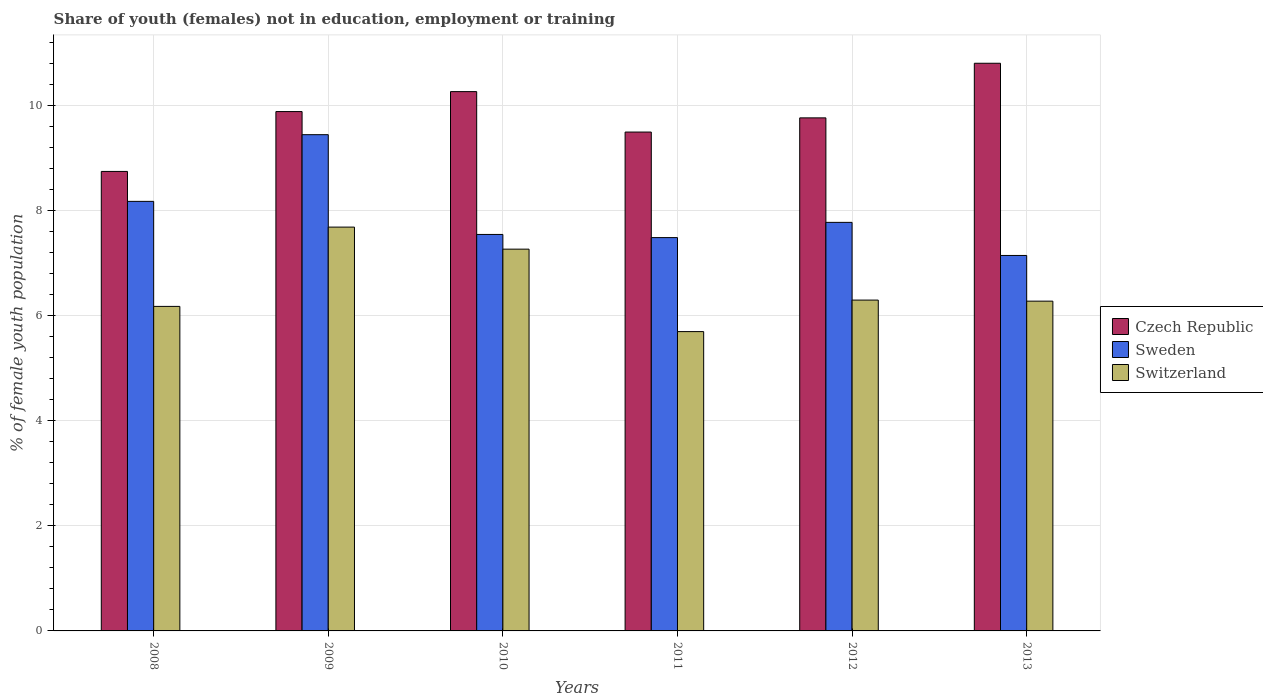Are the number of bars on each tick of the X-axis equal?
Offer a terse response. Yes. What is the label of the 5th group of bars from the left?
Ensure brevity in your answer.  2012. What is the percentage of unemployed female population in in Sweden in 2010?
Your response must be concise. 7.55. Across all years, what is the maximum percentage of unemployed female population in in Czech Republic?
Offer a terse response. 10.81. Across all years, what is the minimum percentage of unemployed female population in in Sweden?
Offer a very short reply. 7.15. What is the total percentage of unemployed female population in in Sweden in the graph?
Give a very brief answer. 47.6. What is the difference between the percentage of unemployed female population in in Switzerland in 2011 and that in 2012?
Your answer should be very brief. -0.6. What is the difference between the percentage of unemployed female population in in Switzerland in 2011 and the percentage of unemployed female population in in Czech Republic in 2012?
Provide a succinct answer. -4.07. What is the average percentage of unemployed female population in in Czech Republic per year?
Your answer should be very brief. 9.83. In the year 2012, what is the difference between the percentage of unemployed female population in in Czech Republic and percentage of unemployed female population in in Sweden?
Your answer should be compact. 1.99. What is the ratio of the percentage of unemployed female population in in Switzerland in 2010 to that in 2013?
Offer a terse response. 1.16. Is the percentage of unemployed female population in in Sweden in 2008 less than that in 2010?
Ensure brevity in your answer.  No. What is the difference between the highest and the second highest percentage of unemployed female population in in Czech Republic?
Provide a succinct answer. 0.54. What is the difference between the highest and the lowest percentage of unemployed female population in in Czech Republic?
Keep it short and to the point. 2.06. In how many years, is the percentage of unemployed female population in in Sweden greater than the average percentage of unemployed female population in in Sweden taken over all years?
Your response must be concise. 2. Is the sum of the percentage of unemployed female population in in Switzerland in 2008 and 2010 greater than the maximum percentage of unemployed female population in in Sweden across all years?
Offer a terse response. Yes. What does the 2nd bar from the left in 2009 represents?
Offer a terse response. Sweden. What does the 3rd bar from the right in 2012 represents?
Your answer should be compact. Czech Republic. Is it the case that in every year, the sum of the percentage of unemployed female population in in Switzerland and percentage of unemployed female population in in Czech Republic is greater than the percentage of unemployed female population in in Sweden?
Your answer should be very brief. Yes. How many bars are there?
Provide a succinct answer. 18. What is the difference between two consecutive major ticks on the Y-axis?
Ensure brevity in your answer.  2. Are the values on the major ticks of Y-axis written in scientific E-notation?
Keep it short and to the point. No. How many legend labels are there?
Your answer should be very brief. 3. How are the legend labels stacked?
Provide a succinct answer. Vertical. What is the title of the graph?
Your answer should be very brief. Share of youth (females) not in education, employment or training. Does "Aruba" appear as one of the legend labels in the graph?
Your answer should be very brief. No. What is the label or title of the Y-axis?
Ensure brevity in your answer.  % of female youth population. What is the % of female youth population of Czech Republic in 2008?
Provide a succinct answer. 8.75. What is the % of female youth population of Sweden in 2008?
Offer a very short reply. 8.18. What is the % of female youth population in Switzerland in 2008?
Keep it short and to the point. 6.18. What is the % of female youth population of Czech Republic in 2009?
Keep it short and to the point. 9.89. What is the % of female youth population of Sweden in 2009?
Give a very brief answer. 9.45. What is the % of female youth population in Switzerland in 2009?
Offer a terse response. 7.69. What is the % of female youth population of Czech Republic in 2010?
Your answer should be compact. 10.27. What is the % of female youth population in Sweden in 2010?
Provide a succinct answer. 7.55. What is the % of female youth population in Switzerland in 2010?
Make the answer very short. 7.27. What is the % of female youth population in Czech Republic in 2011?
Your answer should be very brief. 9.5. What is the % of female youth population in Sweden in 2011?
Offer a very short reply. 7.49. What is the % of female youth population in Switzerland in 2011?
Keep it short and to the point. 5.7. What is the % of female youth population in Czech Republic in 2012?
Your response must be concise. 9.77. What is the % of female youth population of Sweden in 2012?
Give a very brief answer. 7.78. What is the % of female youth population in Switzerland in 2012?
Offer a terse response. 6.3. What is the % of female youth population in Czech Republic in 2013?
Provide a short and direct response. 10.81. What is the % of female youth population of Sweden in 2013?
Provide a short and direct response. 7.15. What is the % of female youth population of Switzerland in 2013?
Your response must be concise. 6.28. Across all years, what is the maximum % of female youth population in Czech Republic?
Provide a succinct answer. 10.81. Across all years, what is the maximum % of female youth population in Sweden?
Your answer should be compact. 9.45. Across all years, what is the maximum % of female youth population in Switzerland?
Keep it short and to the point. 7.69. Across all years, what is the minimum % of female youth population in Czech Republic?
Provide a succinct answer. 8.75. Across all years, what is the minimum % of female youth population in Sweden?
Your response must be concise. 7.15. Across all years, what is the minimum % of female youth population in Switzerland?
Your answer should be compact. 5.7. What is the total % of female youth population in Czech Republic in the graph?
Offer a very short reply. 58.99. What is the total % of female youth population of Sweden in the graph?
Your answer should be compact. 47.6. What is the total % of female youth population of Switzerland in the graph?
Provide a succinct answer. 39.42. What is the difference between the % of female youth population in Czech Republic in 2008 and that in 2009?
Provide a succinct answer. -1.14. What is the difference between the % of female youth population in Sweden in 2008 and that in 2009?
Provide a short and direct response. -1.27. What is the difference between the % of female youth population of Switzerland in 2008 and that in 2009?
Give a very brief answer. -1.51. What is the difference between the % of female youth population in Czech Republic in 2008 and that in 2010?
Offer a terse response. -1.52. What is the difference between the % of female youth population of Sweden in 2008 and that in 2010?
Provide a short and direct response. 0.63. What is the difference between the % of female youth population of Switzerland in 2008 and that in 2010?
Your answer should be very brief. -1.09. What is the difference between the % of female youth population in Czech Republic in 2008 and that in 2011?
Offer a very short reply. -0.75. What is the difference between the % of female youth population of Sweden in 2008 and that in 2011?
Give a very brief answer. 0.69. What is the difference between the % of female youth population in Switzerland in 2008 and that in 2011?
Make the answer very short. 0.48. What is the difference between the % of female youth population of Czech Republic in 2008 and that in 2012?
Provide a succinct answer. -1.02. What is the difference between the % of female youth population of Sweden in 2008 and that in 2012?
Provide a succinct answer. 0.4. What is the difference between the % of female youth population in Switzerland in 2008 and that in 2012?
Make the answer very short. -0.12. What is the difference between the % of female youth population in Czech Republic in 2008 and that in 2013?
Your answer should be compact. -2.06. What is the difference between the % of female youth population in Sweden in 2008 and that in 2013?
Give a very brief answer. 1.03. What is the difference between the % of female youth population in Switzerland in 2008 and that in 2013?
Provide a short and direct response. -0.1. What is the difference between the % of female youth population of Czech Republic in 2009 and that in 2010?
Offer a very short reply. -0.38. What is the difference between the % of female youth population of Switzerland in 2009 and that in 2010?
Provide a succinct answer. 0.42. What is the difference between the % of female youth population in Czech Republic in 2009 and that in 2011?
Provide a short and direct response. 0.39. What is the difference between the % of female youth population of Sweden in 2009 and that in 2011?
Make the answer very short. 1.96. What is the difference between the % of female youth population of Switzerland in 2009 and that in 2011?
Provide a short and direct response. 1.99. What is the difference between the % of female youth population of Czech Republic in 2009 and that in 2012?
Give a very brief answer. 0.12. What is the difference between the % of female youth population of Sweden in 2009 and that in 2012?
Give a very brief answer. 1.67. What is the difference between the % of female youth population of Switzerland in 2009 and that in 2012?
Your answer should be very brief. 1.39. What is the difference between the % of female youth population in Czech Republic in 2009 and that in 2013?
Your response must be concise. -0.92. What is the difference between the % of female youth population in Sweden in 2009 and that in 2013?
Your answer should be compact. 2.3. What is the difference between the % of female youth population in Switzerland in 2009 and that in 2013?
Offer a terse response. 1.41. What is the difference between the % of female youth population of Czech Republic in 2010 and that in 2011?
Provide a succinct answer. 0.77. What is the difference between the % of female youth population of Sweden in 2010 and that in 2011?
Keep it short and to the point. 0.06. What is the difference between the % of female youth population of Switzerland in 2010 and that in 2011?
Ensure brevity in your answer.  1.57. What is the difference between the % of female youth population in Czech Republic in 2010 and that in 2012?
Keep it short and to the point. 0.5. What is the difference between the % of female youth population of Sweden in 2010 and that in 2012?
Offer a terse response. -0.23. What is the difference between the % of female youth population of Czech Republic in 2010 and that in 2013?
Keep it short and to the point. -0.54. What is the difference between the % of female youth population of Czech Republic in 2011 and that in 2012?
Ensure brevity in your answer.  -0.27. What is the difference between the % of female youth population in Sweden in 2011 and that in 2012?
Provide a succinct answer. -0.29. What is the difference between the % of female youth population of Czech Republic in 2011 and that in 2013?
Offer a terse response. -1.31. What is the difference between the % of female youth population of Sweden in 2011 and that in 2013?
Provide a short and direct response. 0.34. What is the difference between the % of female youth population in Switzerland in 2011 and that in 2013?
Offer a very short reply. -0.58. What is the difference between the % of female youth population of Czech Republic in 2012 and that in 2013?
Give a very brief answer. -1.04. What is the difference between the % of female youth population of Sweden in 2012 and that in 2013?
Your response must be concise. 0.63. What is the difference between the % of female youth population of Switzerland in 2012 and that in 2013?
Make the answer very short. 0.02. What is the difference between the % of female youth population in Czech Republic in 2008 and the % of female youth population in Switzerland in 2009?
Your response must be concise. 1.06. What is the difference between the % of female youth population of Sweden in 2008 and the % of female youth population of Switzerland in 2009?
Your answer should be very brief. 0.49. What is the difference between the % of female youth population in Czech Republic in 2008 and the % of female youth population in Sweden in 2010?
Your response must be concise. 1.2. What is the difference between the % of female youth population in Czech Republic in 2008 and the % of female youth population in Switzerland in 2010?
Make the answer very short. 1.48. What is the difference between the % of female youth population of Sweden in 2008 and the % of female youth population of Switzerland in 2010?
Your answer should be very brief. 0.91. What is the difference between the % of female youth population in Czech Republic in 2008 and the % of female youth population in Sweden in 2011?
Make the answer very short. 1.26. What is the difference between the % of female youth population in Czech Republic in 2008 and the % of female youth population in Switzerland in 2011?
Keep it short and to the point. 3.05. What is the difference between the % of female youth population of Sweden in 2008 and the % of female youth population of Switzerland in 2011?
Your answer should be compact. 2.48. What is the difference between the % of female youth population of Czech Republic in 2008 and the % of female youth population of Sweden in 2012?
Ensure brevity in your answer.  0.97. What is the difference between the % of female youth population of Czech Republic in 2008 and the % of female youth population of Switzerland in 2012?
Give a very brief answer. 2.45. What is the difference between the % of female youth population in Sweden in 2008 and the % of female youth population in Switzerland in 2012?
Your response must be concise. 1.88. What is the difference between the % of female youth population in Czech Republic in 2008 and the % of female youth population in Switzerland in 2013?
Your answer should be compact. 2.47. What is the difference between the % of female youth population of Sweden in 2008 and the % of female youth population of Switzerland in 2013?
Provide a short and direct response. 1.9. What is the difference between the % of female youth population of Czech Republic in 2009 and the % of female youth population of Sweden in 2010?
Ensure brevity in your answer.  2.34. What is the difference between the % of female youth population of Czech Republic in 2009 and the % of female youth population of Switzerland in 2010?
Make the answer very short. 2.62. What is the difference between the % of female youth population in Sweden in 2009 and the % of female youth population in Switzerland in 2010?
Provide a succinct answer. 2.18. What is the difference between the % of female youth population of Czech Republic in 2009 and the % of female youth population of Switzerland in 2011?
Your answer should be very brief. 4.19. What is the difference between the % of female youth population of Sweden in 2009 and the % of female youth population of Switzerland in 2011?
Your answer should be compact. 3.75. What is the difference between the % of female youth population in Czech Republic in 2009 and the % of female youth population in Sweden in 2012?
Keep it short and to the point. 2.11. What is the difference between the % of female youth population of Czech Republic in 2009 and the % of female youth population of Switzerland in 2012?
Offer a terse response. 3.59. What is the difference between the % of female youth population in Sweden in 2009 and the % of female youth population in Switzerland in 2012?
Provide a short and direct response. 3.15. What is the difference between the % of female youth population in Czech Republic in 2009 and the % of female youth population in Sweden in 2013?
Your answer should be very brief. 2.74. What is the difference between the % of female youth population in Czech Republic in 2009 and the % of female youth population in Switzerland in 2013?
Ensure brevity in your answer.  3.61. What is the difference between the % of female youth population in Sweden in 2009 and the % of female youth population in Switzerland in 2013?
Your response must be concise. 3.17. What is the difference between the % of female youth population in Czech Republic in 2010 and the % of female youth population in Sweden in 2011?
Your answer should be very brief. 2.78. What is the difference between the % of female youth population in Czech Republic in 2010 and the % of female youth population in Switzerland in 2011?
Keep it short and to the point. 4.57. What is the difference between the % of female youth population in Sweden in 2010 and the % of female youth population in Switzerland in 2011?
Provide a short and direct response. 1.85. What is the difference between the % of female youth population of Czech Republic in 2010 and the % of female youth population of Sweden in 2012?
Offer a very short reply. 2.49. What is the difference between the % of female youth population of Czech Republic in 2010 and the % of female youth population of Switzerland in 2012?
Your answer should be compact. 3.97. What is the difference between the % of female youth population in Sweden in 2010 and the % of female youth population in Switzerland in 2012?
Make the answer very short. 1.25. What is the difference between the % of female youth population of Czech Republic in 2010 and the % of female youth population of Sweden in 2013?
Provide a short and direct response. 3.12. What is the difference between the % of female youth population of Czech Republic in 2010 and the % of female youth population of Switzerland in 2013?
Provide a short and direct response. 3.99. What is the difference between the % of female youth population of Sweden in 2010 and the % of female youth population of Switzerland in 2013?
Keep it short and to the point. 1.27. What is the difference between the % of female youth population of Czech Republic in 2011 and the % of female youth population of Sweden in 2012?
Your answer should be compact. 1.72. What is the difference between the % of female youth population of Czech Republic in 2011 and the % of female youth population of Switzerland in 2012?
Provide a succinct answer. 3.2. What is the difference between the % of female youth population in Sweden in 2011 and the % of female youth population in Switzerland in 2012?
Make the answer very short. 1.19. What is the difference between the % of female youth population in Czech Republic in 2011 and the % of female youth population in Sweden in 2013?
Give a very brief answer. 2.35. What is the difference between the % of female youth population of Czech Republic in 2011 and the % of female youth population of Switzerland in 2013?
Give a very brief answer. 3.22. What is the difference between the % of female youth population of Sweden in 2011 and the % of female youth population of Switzerland in 2013?
Provide a short and direct response. 1.21. What is the difference between the % of female youth population in Czech Republic in 2012 and the % of female youth population in Sweden in 2013?
Make the answer very short. 2.62. What is the difference between the % of female youth population in Czech Republic in 2012 and the % of female youth population in Switzerland in 2013?
Offer a terse response. 3.49. What is the average % of female youth population in Czech Republic per year?
Make the answer very short. 9.83. What is the average % of female youth population in Sweden per year?
Provide a succinct answer. 7.93. What is the average % of female youth population of Switzerland per year?
Offer a terse response. 6.57. In the year 2008, what is the difference between the % of female youth population in Czech Republic and % of female youth population in Sweden?
Your response must be concise. 0.57. In the year 2008, what is the difference between the % of female youth population of Czech Republic and % of female youth population of Switzerland?
Your answer should be compact. 2.57. In the year 2009, what is the difference between the % of female youth population in Czech Republic and % of female youth population in Sweden?
Offer a very short reply. 0.44. In the year 2009, what is the difference between the % of female youth population in Sweden and % of female youth population in Switzerland?
Your answer should be compact. 1.76. In the year 2010, what is the difference between the % of female youth population of Czech Republic and % of female youth population of Sweden?
Ensure brevity in your answer.  2.72. In the year 2010, what is the difference between the % of female youth population in Czech Republic and % of female youth population in Switzerland?
Your answer should be compact. 3. In the year 2010, what is the difference between the % of female youth population in Sweden and % of female youth population in Switzerland?
Keep it short and to the point. 0.28. In the year 2011, what is the difference between the % of female youth population in Czech Republic and % of female youth population in Sweden?
Your response must be concise. 2.01. In the year 2011, what is the difference between the % of female youth population of Czech Republic and % of female youth population of Switzerland?
Ensure brevity in your answer.  3.8. In the year 2011, what is the difference between the % of female youth population in Sweden and % of female youth population in Switzerland?
Provide a short and direct response. 1.79. In the year 2012, what is the difference between the % of female youth population in Czech Republic and % of female youth population in Sweden?
Your answer should be very brief. 1.99. In the year 2012, what is the difference between the % of female youth population of Czech Republic and % of female youth population of Switzerland?
Provide a short and direct response. 3.47. In the year 2012, what is the difference between the % of female youth population of Sweden and % of female youth population of Switzerland?
Ensure brevity in your answer.  1.48. In the year 2013, what is the difference between the % of female youth population of Czech Republic and % of female youth population of Sweden?
Offer a very short reply. 3.66. In the year 2013, what is the difference between the % of female youth population of Czech Republic and % of female youth population of Switzerland?
Ensure brevity in your answer.  4.53. In the year 2013, what is the difference between the % of female youth population of Sweden and % of female youth population of Switzerland?
Give a very brief answer. 0.87. What is the ratio of the % of female youth population in Czech Republic in 2008 to that in 2009?
Your answer should be compact. 0.88. What is the ratio of the % of female youth population in Sweden in 2008 to that in 2009?
Provide a short and direct response. 0.87. What is the ratio of the % of female youth population of Switzerland in 2008 to that in 2009?
Offer a terse response. 0.8. What is the ratio of the % of female youth population of Czech Republic in 2008 to that in 2010?
Offer a very short reply. 0.85. What is the ratio of the % of female youth population of Sweden in 2008 to that in 2010?
Provide a succinct answer. 1.08. What is the ratio of the % of female youth population of Switzerland in 2008 to that in 2010?
Your answer should be compact. 0.85. What is the ratio of the % of female youth population in Czech Republic in 2008 to that in 2011?
Your answer should be compact. 0.92. What is the ratio of the % of female youth population of Sweden in 2008 to that in 2011?
Keep it short and to the point. 1.09. What is the ratio of the % of female youth population in Switzerland in 2008 to that in 2011?
Offer a terse response. 1.08. What is the ratio of the % of female youth population in Czech Republic in 2008 to that in 2012?
Your response must be concise. 0.9. What is the ratio of the % of female youth population in Sweden in 2008 to that in 2012?
Ensure brevity in your answer.  1.05. What is the ratio of the % of female youth population of Switzerland in 2008 to that in 2012?
Give a very brief answer. 0.98. What is the ratio of the % of female youth population in Czech Republic in 2008 to that in 2013?
Offer a very short reply. 0.81. What is the ratio of the % of female youth population of Sweden in 2008 to that in 2013?
Provide a short and direct response. 1.14. What is the ratio of the % of female youth population in Switzerland in 2008 to that in 2013?
Offer a very short reply. 0.98. What is the ratio of the % of female youth population of Czech Republic in 2009 to that in 2010?
Make the answer very short. 0.96. What is the ratio of the % of female youth population in Sweden in 2009 to that in 2010?
Offer a very short reply. 1.25. What is the ratio of the % of female youth population in Switzerland in 2009 to that in 2010?
Keep it short and to the point. 1.06. What is the ratio of the % of female youth population of Czech Republic in 2009 to that in 2011?
Your answer should be compact. 1.04. What is the ratio of the % of female youth population in Sweden in 2009 to that in 2011?
Offer a very short reply. 1.26. What is the ratio of the % of female youth population of Switzerland in 2009 to that in 2011?
Keep it short and to the point. 1.35. What is the ratio of the % of female youth population of Czech Republic in 2009 to that in 2012?
Provide a succinct answer. 1.01. What is the ratio of the % of female youth population of Sweden in 2009 to that in 2012?
Keep it short and to the point. 1.21. What is the ratio of the % of female youth population of Switzerland in 2009 to that in 2012?
Offer a terse response. 1.22. What is the ratio of the % of female youth population in Czech Republic in 2009 to that in 2013?
Provide a short and direct response. 0.91. What is the ratio of the % of female youth population of Sweden in 2009 to that in 2013?
Offer a terse response. 1.32. What is the ratio of the % of female youth population in Switzerland in 2009 to that in 2013?
Give a very brief answer. 1.22. What is the ratio of the % of female youth population of Czech Republic in 2010 to that in 2011?
Offer a very short reply. 1.08. What is the ratio of the % of female youth population in Switzerland in 2010 to that in 2011?
Give a very brief answer. 1.28. What is the ratio of the % of female youth population of Czech Republic in 2010 to that in 2012?
Your answer should be very brief. 1.05. What is the ratio of the % of female youth population of Sweden in 2010 to that in 2012?
Your answer should be very brief. 0.97. What is the ratio of the % of female youth population in Switzerland in 2010 to that in 2012?
Give a very brief answer. 1.15. What is the ratio of the % of female youth population of Sweden in 2010 to that in 2013?
Provide a short and direct response. 1.06. What is the ratio of the % of female youth population in Switzerland in 2010 to that in 2013?
Ensure brevity in your answer.  1.16. What is the ratio of the % of female youth population of Czech Republic in 2011 to that in 2012?
Give a very brief answer. 0.97. What is the ratio of the % of female youth population of Sweden in 2011 to that in 2012?
Make the answer very short. 0.96. What is the ratio of the % of female youth population in Switzerland in 2011 to that in 2012?
Offer a terse response. 0.9. What is the ratio of the % of female youth population in Czech Republic in 2011 to that in 2013?
Offer a terse response. 0.88. What is the ratio of the % of female youth population of Sweden in 2011 to that in 2013?
Give a very brief answer. 1.05. What is the ratio of the % of female youth population in Switzerland in 2011 to that in 2013?
Offer a terse response. 0.91. What is the ratio of the % of female youth population of Czech Republic in 2012 to that in 2013?
Offer a very short reply. 0.9. What is the ratio of the % of female youth population of Sweden in 2012 to that in 2013?
Ensure brevity in your answer.  1.09. What is the ratio of the % of female youth population in Switzerland in 2012 to that in 2013?
Your answer should be compact. 1. What is the difference between the highest and the second highest % of female youth population of Czech Republic?
Provide a short and direct response. 0.54. What is the difference between the highest and the second highest % of female youth population in Sweden?
Offer a terse response. 1.27. What is the difference between the highest and the second highest % of female youth population in Switzerland?
Keep it short and to the point. 0.42. What is the difference between the highest and the lowest % of female youth population in Czech Republic?
Give a very brief answer. 2.06. What is the difference between the highest and the lowest % of female youth population in Sweden?
Provide a short and direct response. 2.3. What is the difference between the highest and the lowest % of female youth population of Switzerland?
Ensure brevity in your answer.  1.99. 